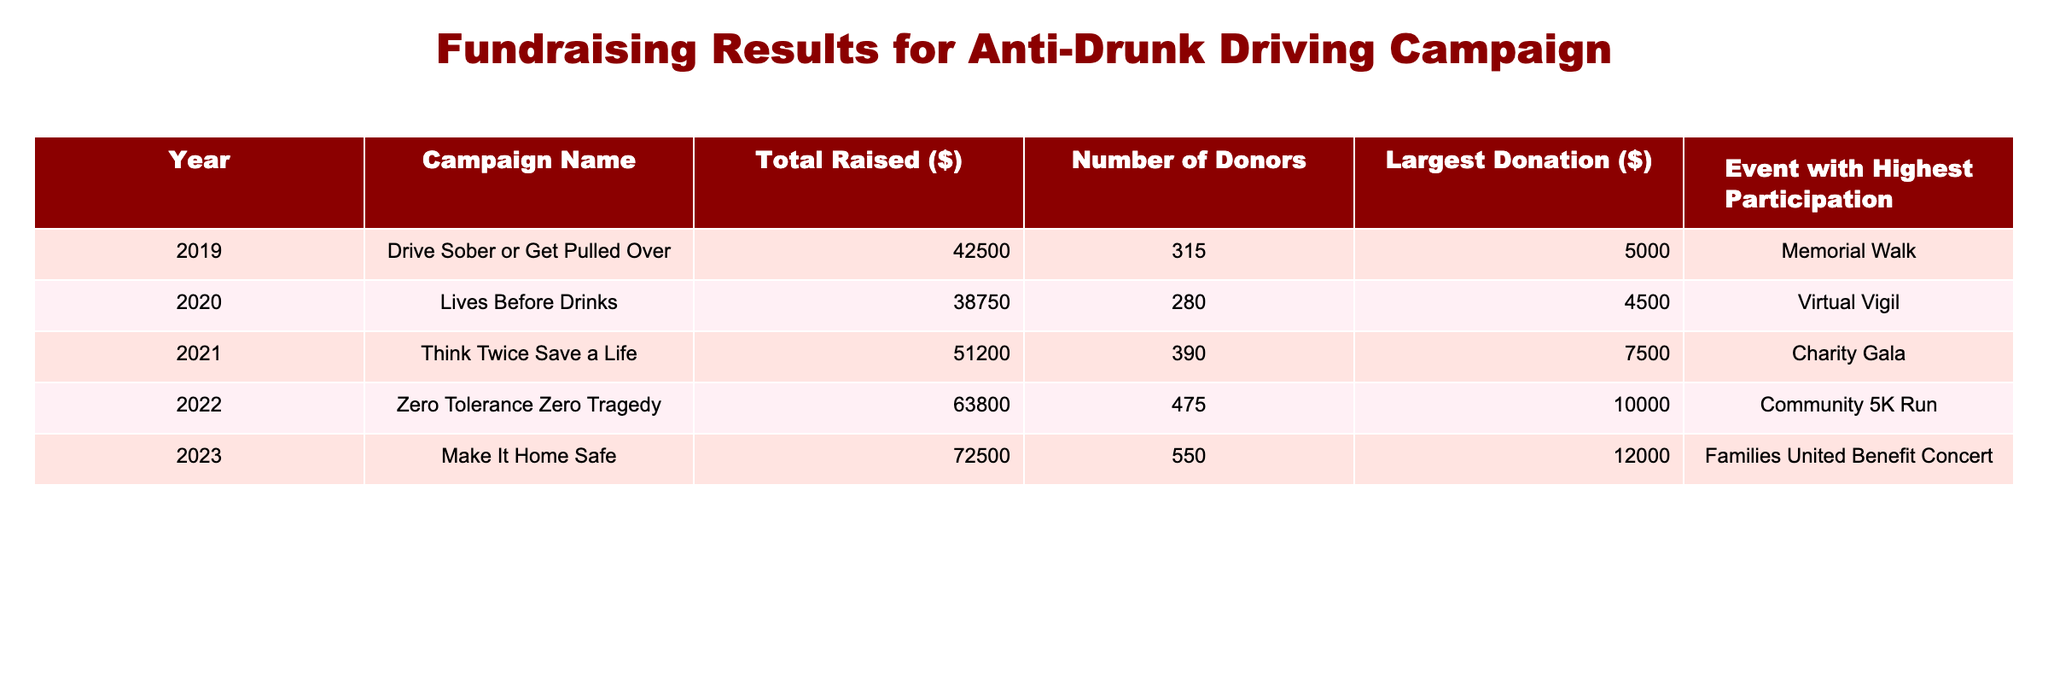What campaign raised the highest amount of total funds? By reviewing the "Total Raised ($)" column, we can see that the campaign "Make It Home Safe" in 2023 raised the highest amount of $72,500.
Answer: Make It Home Safe How many donors contributed to the "Zero Tolerance Zero Tragedy" campaign? Looking at the "Number of Donors" column for the "Zero Tolerance Zero Tragedy" campaign in 2022, it shows there were 475 donors.
Answer: 475 What was the largest donation amount in 2021? From the "Largest Donation ($)" column for the year 2021, the largest donation amount was $7,500.
Answer: $7,500 What is the average total amount raised across all campaigns from 2019 to 2023? To find the average, we sum the total amounts raised from each year: 42,500 + 38,750 + 51,200 + 63,800 + 72,500 = 268,750. Then we divide by 5 (the number of campaigns): 268,750 / 5 = 53,750.
Answer: $53,750 Did any campaign have more than 500 donors? By checking the "Number of Donors" column, we see that the campaign "Make It Home Safe" in 2023 had 550 donors, which is more than 500.
Answer: Yes What event had the highest participation in 2020? In the 2020 row, the event with the highest participation is listed as the "Virtual Vigil."
Answer: Virtual Vigil What was the total amount raised in 2022 compared to 2020? The total raised in 2022 was $63,800 and in 2020 was $38,750. The difference is $63,800 - $38,750 = $25,050.
Answer: $25,050 Which campaign had the largest donation amount, and how much was it? The campaign "Make It Home Safe" raised the largest donation amount at $12,000 in 2023.
Answer: $12,000 How much more total money was raised in 2023 than in 2019? The total raised in 2023 was $72,500 and in 2019 was $42,500. The difference is $72,500 - $42,500 = $30,000.
Answer: $30,000 Which year saw the least amount of money raised, and how much was it? The least amount raised is found in 2020 with $38,750.
Answer: 2020, $38,750 